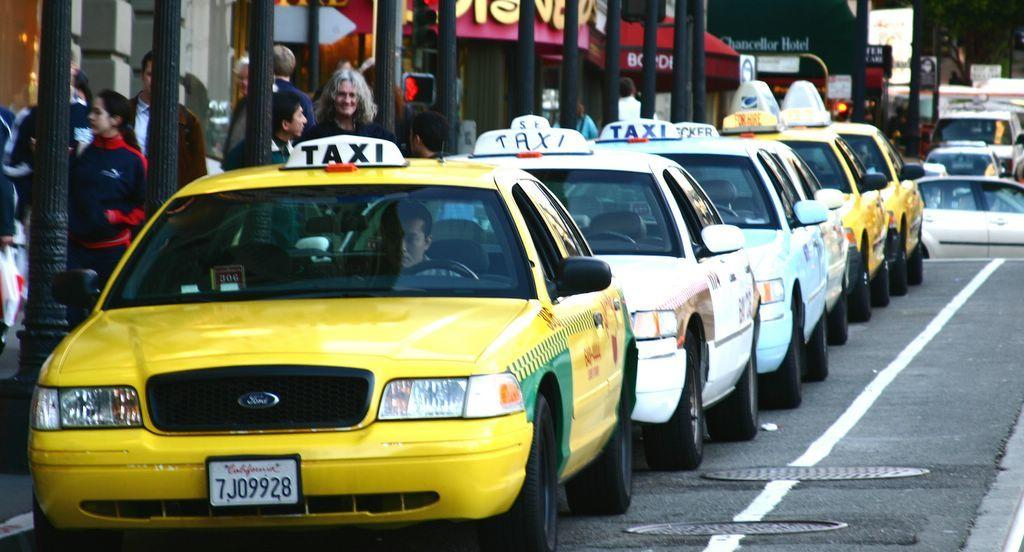<image>
Write a terse but informative summary of the picture. a group of taxis and one with a california license plate 